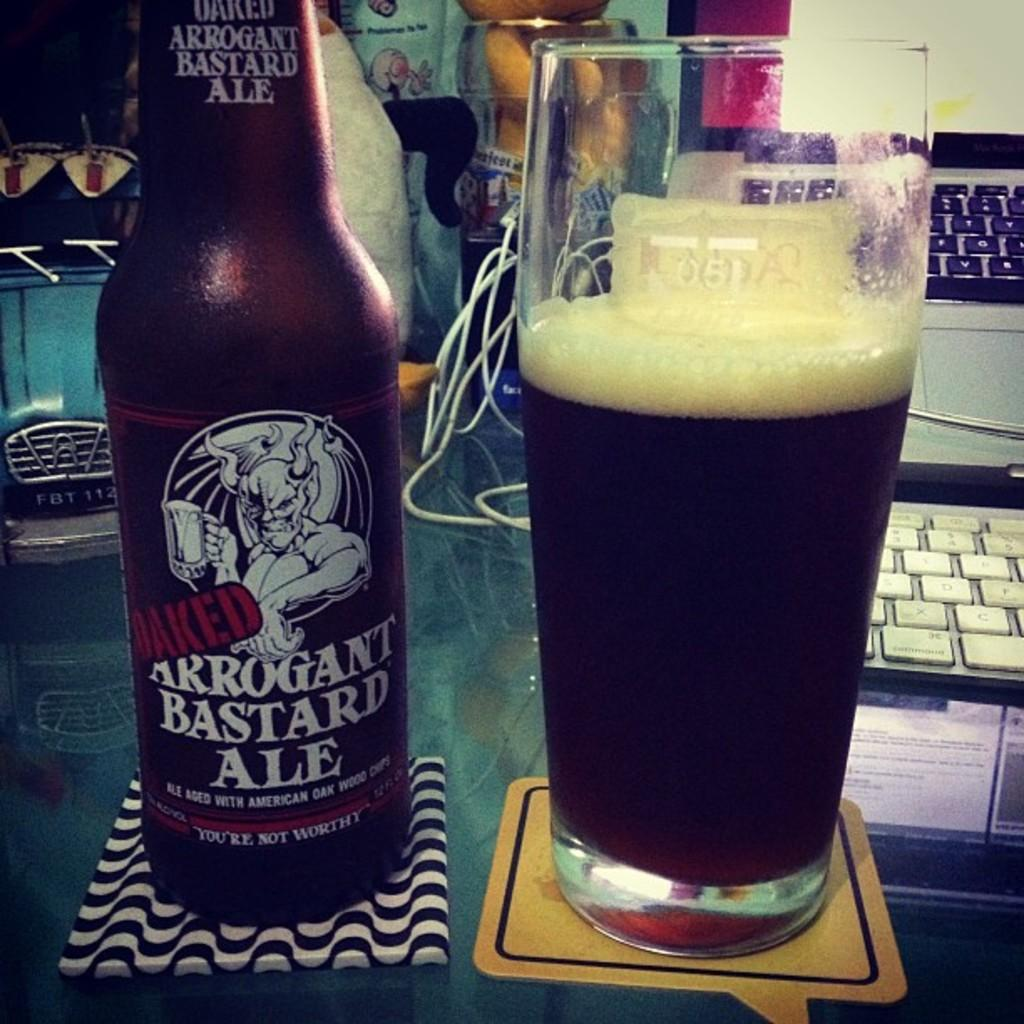<image>
Create a compact narrative representing the image presented. a bottle and glass of Arrogant Bastard Ale on coasters 